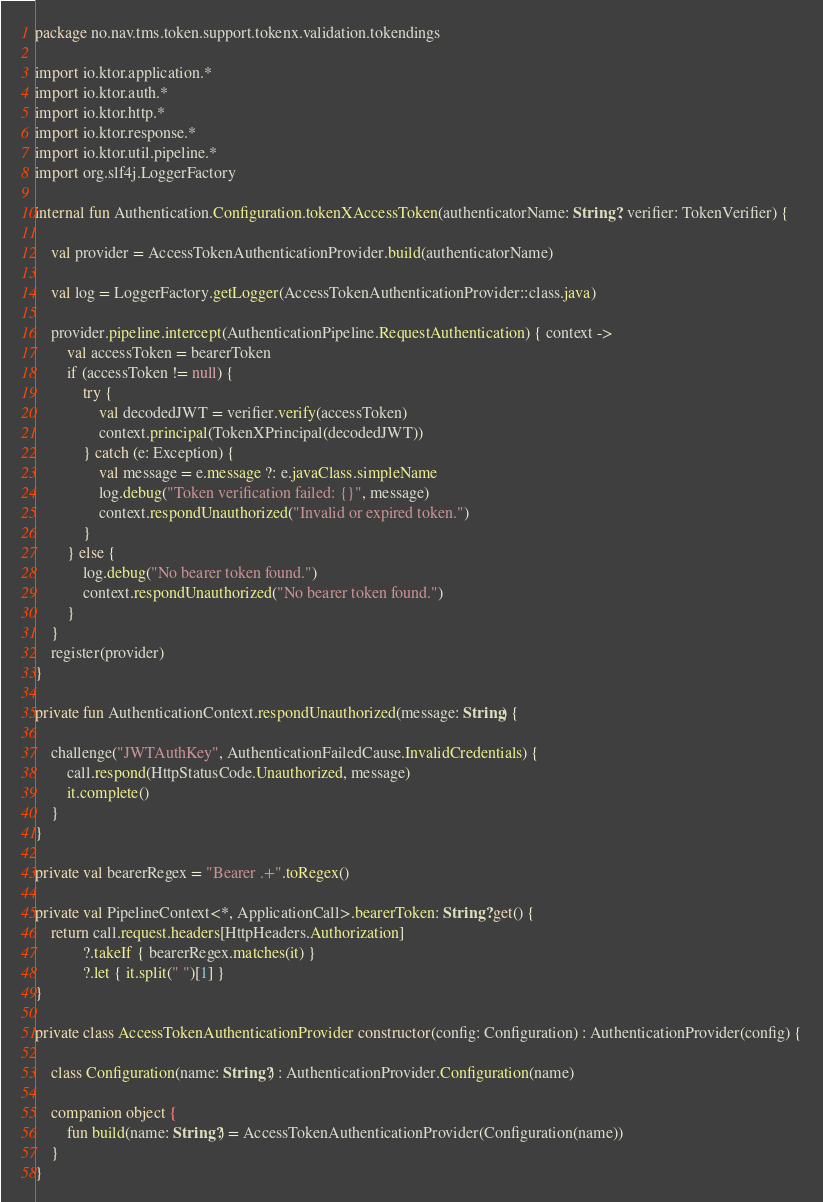Convert code to text. <code><loc_0><loc_0><loc_500><loc_500><_Kotlin_>package no.nav.tms.token.support.tokenx.validation.tokendings

import io.ktor.application.*
import io.ktor.auth.*
import io.ktor.http.*
import io.ktor.response.*
import io.ktor.util.pipeline.*
import org.slf4j.LoggerFactory

internal fun Authentication.Configuration.tokenXAccessToken(authenticatorName: String?, verifier: TokenVerifier) {

    val provider = AccessTokenAuthenticationProvider.build(authenticatorName)

    val log = LoggerFactory.getLogger(AccessTokenAuthenticationProvider::class.java)

    provider.pipeline.intercept(AuthenticationPipeline.RequestAuthentication) { context ->
        val accessToken = bearerToken
        if (accessToken != null) {
            try {
                val decodedJWT = verifier.verify(accessToken)
                context.principal(TokenXPrincipal(decodedJWT))
            } catch (e: Exception) {
                val message = e.message ?: e.javaClass.simpleName
                log.debug("Token verification failed: {}", message)
                context.respondUnauthorized("Invalid or expired token.")
            }
        } else {
            log.debug("No bearer token found.")
            context.respondUnauthorized("No bearer token found.")
        }
    }
    register(provider)
}

private fun AuthenticationContext.respondUnauthorized(message: String) {

    challenge("JWTAuthKey", AuthenticationFailedCause.InvalidCredentials) {
        call.respond(HttpStatusCode.Unauthorized, message)
        it.complete()
    }
}

private val bearerRegex = "Bearer .+".toRegex()

private val PipelineContext<*, ApplicationCall>.bearerToken: String? get() {
    return call.request.headers[HttpHeaders.Authorization]
            ?.takeIf { bearerRegex.matches(it) }
            ?.let { it.split(" ")[1] }
}

private class AccessTokenAuthenticationProvider constructor(config: Configuration) : AuthenticationProvider(config) {

    class Configuration(name: String?) : AuthenticationProvider.Configuration(name)

    companion object {
        fun build(name: String?) = AccessTokenAuthenticationProvider(Configuration(name))
    }
}
</code> 